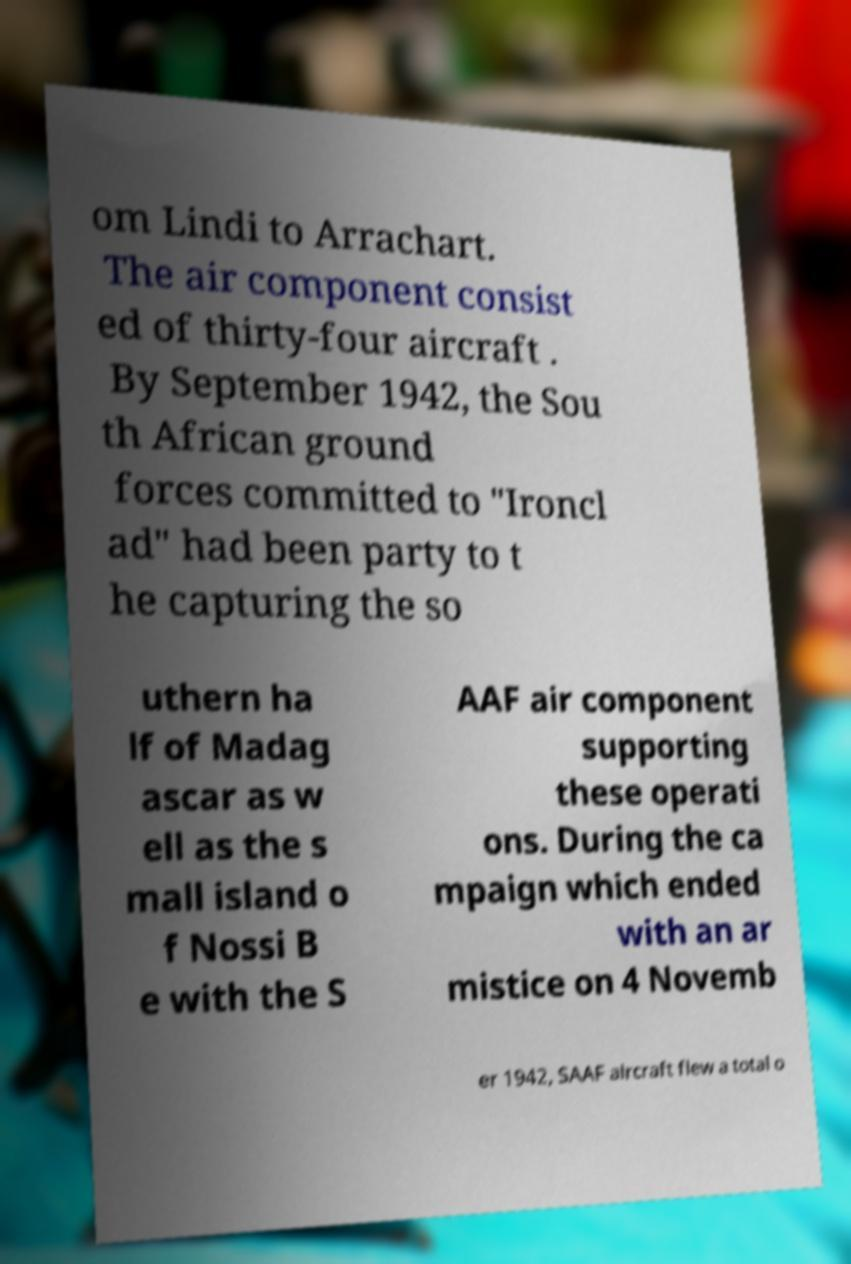I need the written content from this picture converted into text. Can you do that? om Lindi to Arrachart. The air component consist ed of thirty-four aircraft . By September 1942, the Sou th African ground forces committed to "Ironcl ad" had been party to t he capturing the so uthern ha lf of Madag ascar as w ell as the s mall island o f Nossi B e with the S AAF air component supporting these operati ons. During the ca mpaign which ended with an ar mistice on 4 Novemb er 1942, SAAF aircraft flew a total o 